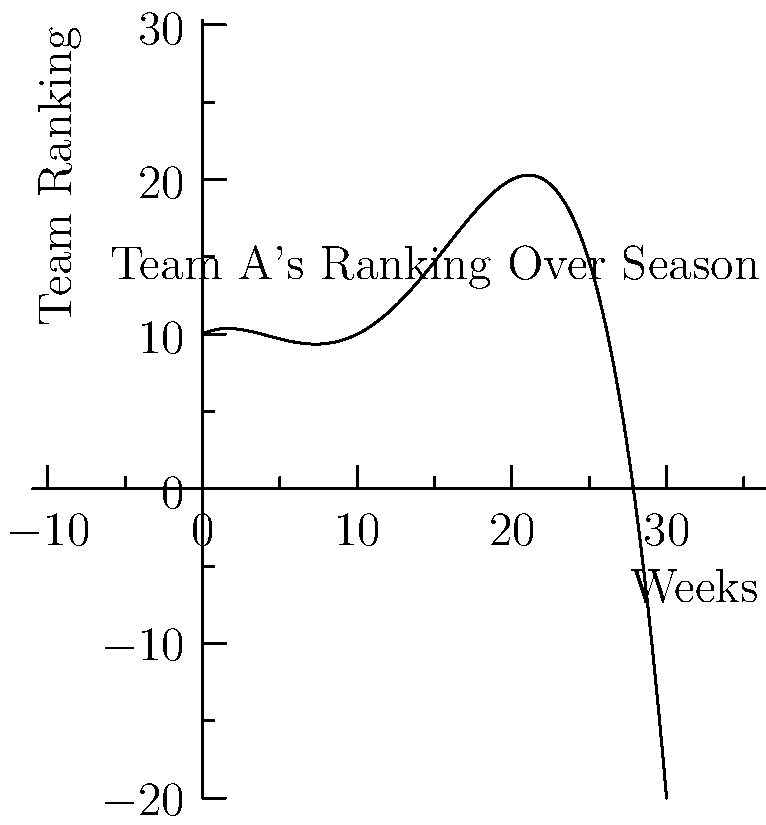The graph shows Team A's ranking throughout a 30-week sports season. Based on the polynomial curve, during which period did Team A experience their most significant improvement in ranking? To determine the period of most significant improvement, we need to analyze the slope of the curve:

1. The curve is represented by a 4th-degree polynomial function.
2. The steepest negative slope indicates the fastest improvement in ranking (as lower numbers typically represent better rankings).
3. Visually, we can see that the curve descends most rapidly between weeks 5 and 15.
4. The inflection point, where the curve changes from concave down to concave up, occurs around week 10.
5. This inflection point represents the middle of the period of fastest improvement.
6. Therefore, the period of most significant improvement is centered around week 10, extending approximately 5 weeks before and after.

While data analysis might suggest a more precise answer, visual interpretation of the curve supports this conclusion, aligning with the perspective of a professional athlete who may rely more on intuition and experience than pure data.
Answer: Weeks 5-15 